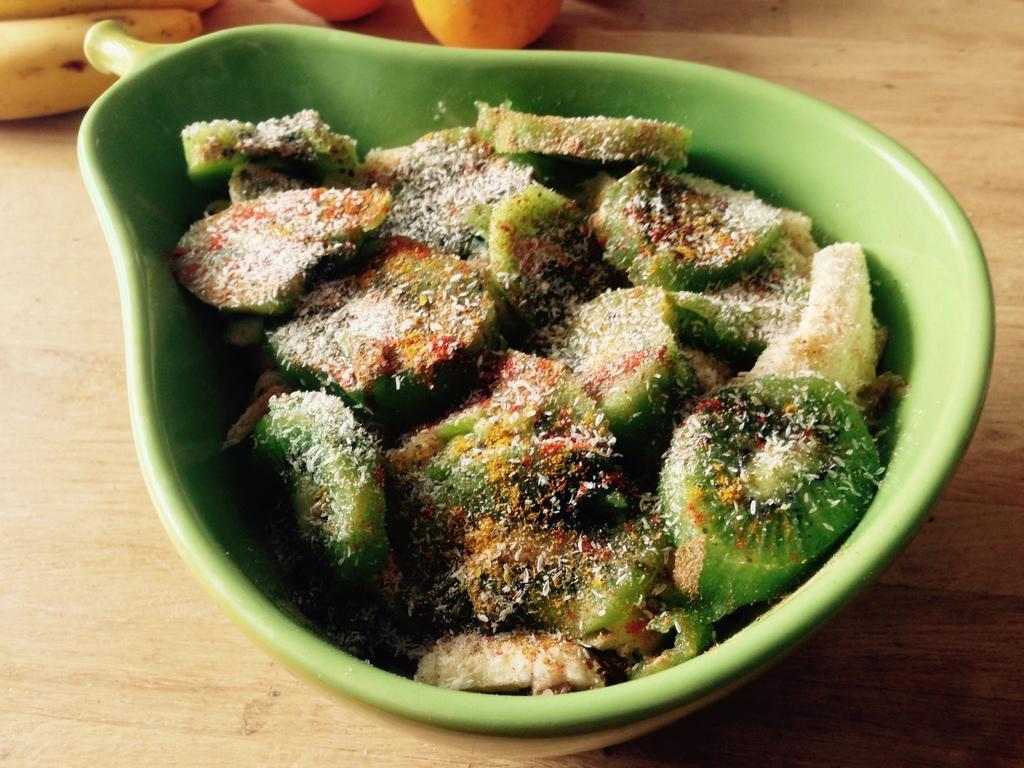How would you summarize this image in a sentence or two? In this image in a bowl there are some slices of fruits. On the table there are bananas and oranges. 